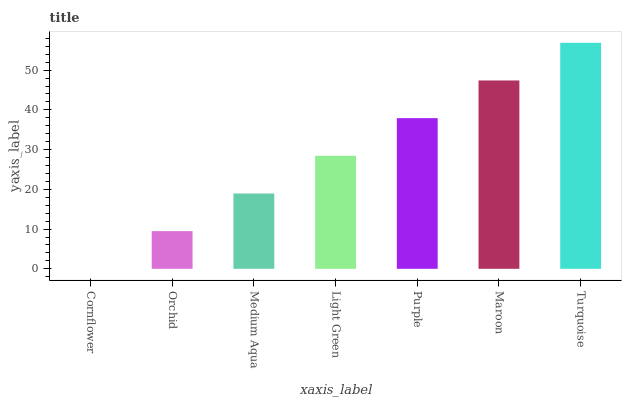Is Orchid the minimum?
Answer yes or no. No. Is Orchid the maximum?
Answer yes or no. No. Is Orchid greater than Cornflower?
Answer yes or no. Yes. Is Cornflower less than Orchid?
Answer yes or no. Yes. Is Cornflower greater than Orchid?
Answer yes or no. No. Is Orchid less than Cornflower?
Answer yes or no. No. Is Light Green the high median?
Answer yes or no. Yes. Is Light Green the low median?
Answer yes or no. Yes. Is Turquoise the high median?
Answer yes or no. No. Is Cornflower the low median?
Answer yes or no. No. 